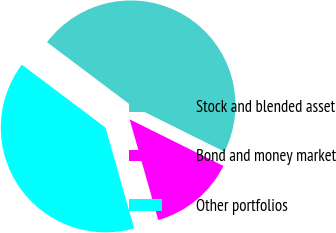<chart> <loc_0><loc_0><loc_500><loc_500><pie_chart><fcel>Stock and blended asset<fcel>Bond and money market<fcel>Other portfolios<nl><fcel>47.07%<fcel>13.26%<fcel>39.67%<nl></chart> 